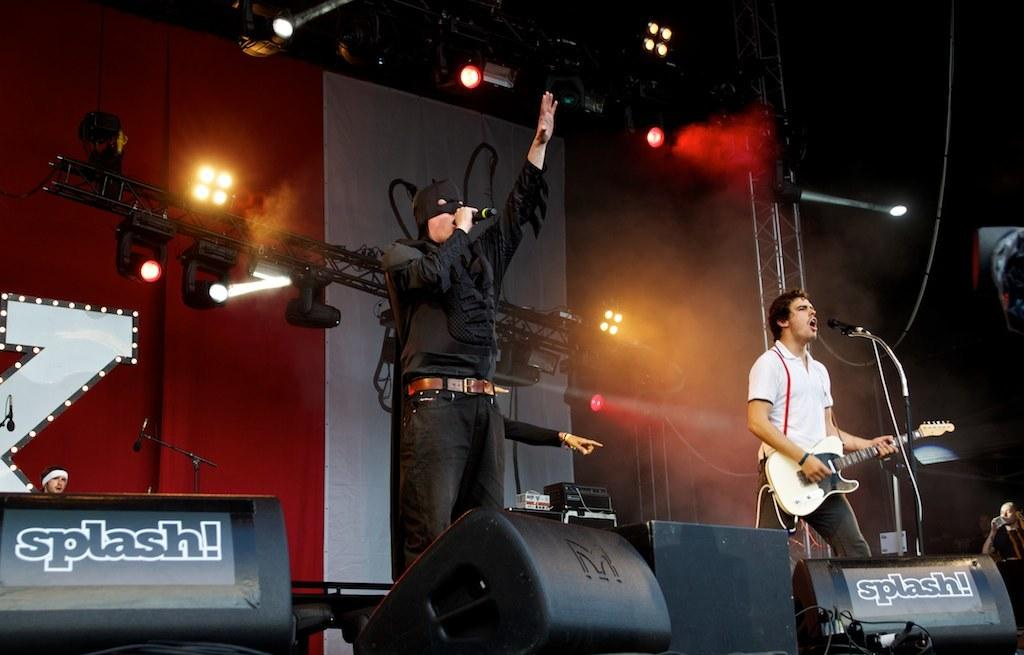What is the person in the image wearing? The person is wearing a Batman dress in the image. What is the person doing while wearing the Batman dress? The person is singing in the image. What can be seen in front of the person while they are singing? The person is in front of a microphone. Can you describe the other person in the image? The second person is also in the image, and they are playing a guitar. What is the second person doing while playing the guitar? The second person is singing and playing the guitar in the image. What is in front of the second person while they are singing and playing the guitar? The second person is also in front of a microphone. What type of crate is being used as a prop in the image? There is no crate present in the image. What role does the celery play in the performance in the image? There is no celery present in the image, so it cannot play a role in the performance. 